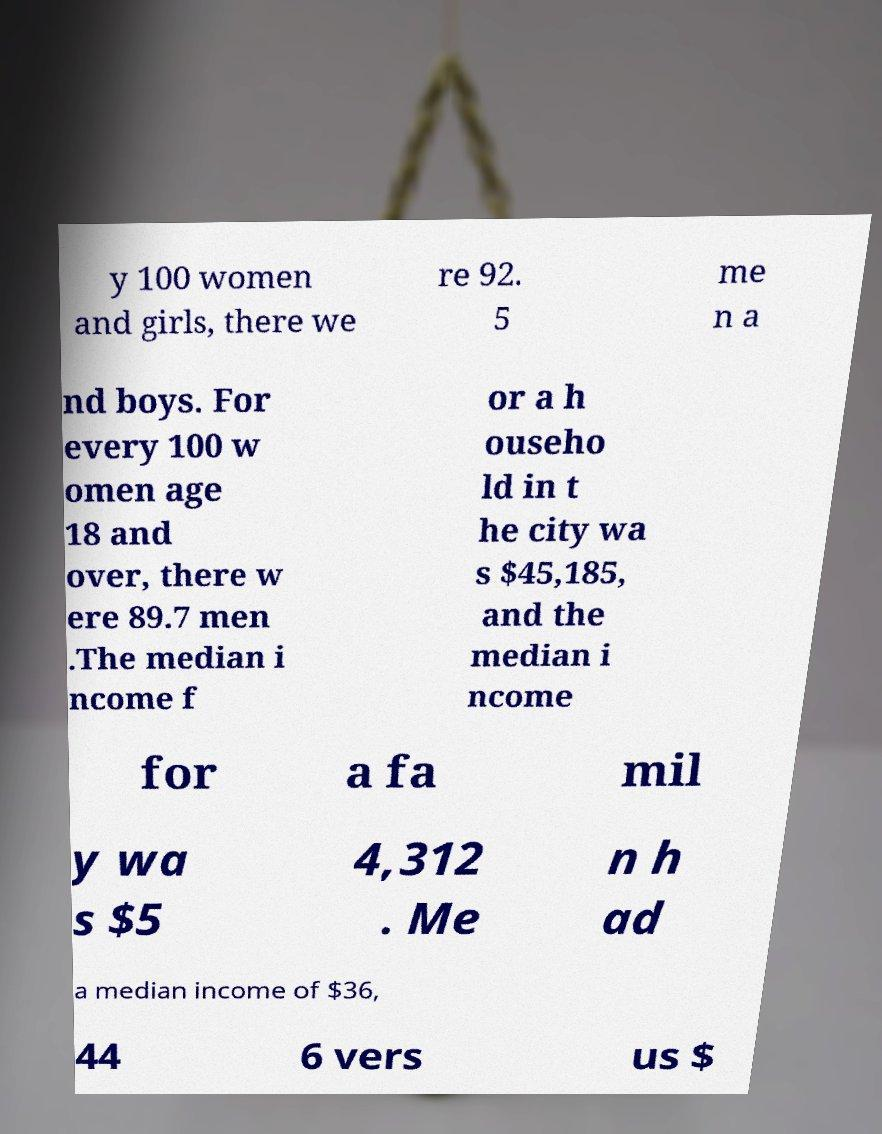There's text embedded in this image that I need extracted. Can you transcribe it verbatim? y 100 women and girls, there we re 92. 5 me n a nd boys. For every 100 w omen age 18 and over, there w ere 89.7 men .The median i ncome f or a h ouseho ld in t he city wa s $45,185, and the median i ncome for a fa mil y wa s $5 4,312 . Me n h ad a median income of $36, 44 6 vers us $ 